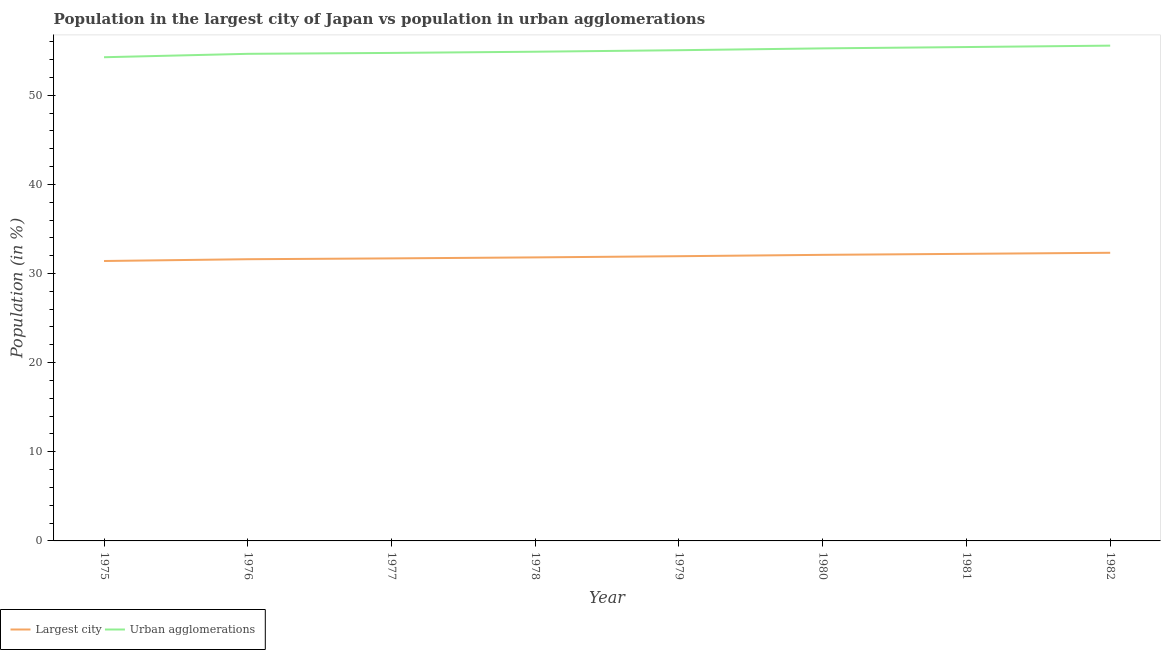Does the line corresponding to population in the largest city intersect with the line corresponding to population in urban agglomerations?
Make the answer very short. No. What is the population in the largest city in 1979?
Offer a very short reply. 31.94. Across all years, what is the maximum population in the largest city?
Provide a short and direct response. 32.32. Across all years, what is the minimum population in urban agglomerations?
Keep it short and to the point. 54.26. In which year was the population in urban agglomerations minimum?
Your answer should be very brief. 1975. What is the total population in the largest city in the graph?
Provide a succinct answer. 255.06. What is the difference between the population in the largest city in 1976 and that in 1978?
Make the answer very short. -0.21. What is the difference between the population in urban agglomerations in 1975 and the population in the largest city in 1980?
Keep it short and to the point. 22.17. What is the average population in the largest city per year?
Ensure brevity in your answer.  31.88. In the year 1975, what is the difference between the population in urban agglomerations and population in the largest city?
Provide a short and direct response. 22.86. In how many years, is the population in the largest city greater than 4 %?
Your answer should be compact. 8. What is the ratio of the population in the largest city in 1979 to that in 1982?
Make the answer very short. 0.99. What is the difference between the highest and the second highest population in urban agglomerations?
Provide a succinct answer. 0.16. What is the difference between the highest and the lowest population in the largest city?
Provide a succinct answer. 0.92. How many years are there in the graph?
Give a very brief answer. 8. What is the difference between two consecutive major ticks on the Y-axis?
Provide a succinct answer. 10. Are the values on the major ticks of Y-axis written in scientific E-notation?
Your response must be concise. No. Does the graph contain any zero values?
Ensure brevity in your answer.  No. Where does the legend appear in the graph?
Ensure brevity in your answer.  Bottom left. How many legend labels are there?
Give a very brief answer. 2. How are the legend labels stacked?
Make the answer very short. Horizontal. What is the title of the graph?
Offer a terse response. Population in the largest city of Japan vs population in urban agglomerations. Does "Not attending school" appear as one of the legend labels in the graph?
Your answer should be very brief. No. What is the label or title of the Y-axis?
Keep it short and to the point. Population (in %). What is the Population (in %) of Largest city in 1975?
Provide a short and direct response. 31.4. What is the Population (in %) in Urban agglomerations in 1975?
Offer a terse response. 54.26. What is the Population (in %) in Largest city in 1976?
Your answer should be very brief. 31.6. What is the Population (in %) of Urban agglomerations in 1976?
Your answer should be very brief. 54.64. What is the Population (in %) in Largest city in 1977?
Ensure brevity in your answer.  31.69. What is the Population (in %) of Urban agglomerations in 1977?
Provide a short and direct response. 54.74. What is the Population (in %) in Largest city in 1978?
Make the answer very short. 31.81. What is the Population (in %) in Urban agglomerations in 1978?
Provide a short and direct response. 54.88. What is the Population (in %) in Largest city in 1979?
Provide a short and direct response. 31.94. What is the Population (in %) in Urban agglomerations in 1979?
Make the answer very short. 55.05. What is the Population (in %) in Largest city in 1980?
Keep it short and to the point. 32.09. What is the Population (in %) of Urban agglomerations in 1980?
Provide a succinct answer. 55.25. What is the Population (in %) in Largest city in 1981?
Keep it short and to the point. 32.21. What is the Population (in %) of Urban agglomerations in 1981?
Your answer should be very brief. 55.4. What is the Population (in %) in Largest city in 1982?
Your response must be concise. 32.32. What is the Population (in %) in Urban agglomerations in 1982?
Your answer should be very brief. 55.56. Across all years, what is the maximum Population (in %) of Largest city?
Make the answer very short. 32.32. Across all years, what is the maximum Population (in %) in Urban agglomerations?
Provide a succinct answer. 55.56. Across all years, what is the minimum Population (in %) in Largest city?
Your answer should be very brief. 31.4. Across all years, what is the minimum Population (in %) in Urban agglomerations?
Your response must be concise. 54.26. What is the total Population (in %) of Largest city in the graph?
Your answer should be very brief. 255.06. What is the total Population (in %) of Urban agglomerations in the graph?
Your answer should be compact. 439.79. What is the difference between the Population (in %) in Largest city in 1975 and that in 1976?
Offer a very short reply. -0.2. What is the difference between the Population (in %) of Urban agglomerations in 1975 and that in 1976?
Offer a very short reply. -0.38. What is the difference between the Population (in %) of Largest city in 1975 and that in 1977?
Provide a succinct answer. -0.29. What is the difference between the Population (in %) in Urban agglomerations in 1975 and that in 1977?
Your answer should be compact. -0.48. What is the difference between the Population (in %) of Largest city in 1975 and that in 1978?
Offer a terse response. -0.4. What is the difference between the Population (in %) in Urban agglomerations in 1975 and that in 1978?
Make the answer very short. -0.62. What is the difference between the Population (in %) in Largest city in 1975 and that in 1979?
Offer a very short reply. -0.54. What is the difference between the Population (in %) in Urban agglomerations in 1975 and that in 1979?
Provide a short and direct response. -0.79. What is the difference between the Population (in %) of Largest city in 1975 and that in 1980?
Give a very brief answer. -0.69. What is the difference between the Population (in %) in Urban agglomerations in 1975 and that in 1980?
Provide a succinct answer. -0.99. What is the difference between the Population (in %) in Largest city in 1975 and that in 1981?
Give a very brief answer. -0.8. What is the difference between the Population (in %) in Urban agglomerations in 1975 and that in 1981?
Make the answer very short. -1.14. What is the difference between the Population (in %) in Largest city in 1975 and that in 1982?
Provide a succinct answer. -0.92. What is the difference between the Population (in %) of Urban agglomerations in 1975 and that in 1982?
Your answer should be very brief. -1.3. What is the difference between the Population (in %) of Largest city in 1976 and that in 1977?
Provide a short and direct response. -0.09. What is the difference between the Population (in %) of Urban agglomerations in 1976 and that in 1977?
Ensure brevity in your answer.  -0.1. What is the difference between the Population (in %) in Largest city in 1976 and that in 1978?
Give a very brief answer. -0.21. What is the difference between the Population (in %) of Urban agglomerations in 1976 and that in 1978?
Keep it short and to the point. -0.24. What is the difference between the Population (in %) of Largest city in 1976 and that in 1979?
Your response must be concise. -0.34. What is the difference between the Population (in %) of Urban agglomerations in 1976 and that in 1979?
Your response must be concise. -0.41. What is the difference between the Population (in %) of Largest city in 1976 and that in 1980?
Offer a very short reply. -0.49. What is the difference between the Population (in %) in Urban agglomerations in 1976 and that in 1980?
Keep it short and to the point. -0.61. What is the difference between the Population (in %) in Largest city in 1976 and that in 1981?
Your response must be concise. -0.61. What is the difference between the Population (in %) of Urban agglomerations in 1976 and that in 1981?
Make the answer very short. -0.76. What is the difference between the Population (in %) in Largest city in 1976 and that in 1982?
Make the answer very short. -0.72. What is the difference between the Population (in %) in Urban agglomerations in 1976 and that in 1982?
Keep it short and to the point. -0.92. What is the difference between the Population (in %) in Largest city in 1977 and that in 1978?
Provide a succinct answer. -0.11. What is the difference between the Population (in %) in Urban agglomerations in 1977 and that in 1978?
Your answer should be very brief. -0.14. What is the difference between the Population (in %) of Largest city in 1977 and that in 1979?
Give a very brief answer. -0.25. What is the difference between the Population (in %) in Urban agglomerations in 1977 and that in 1979?
Keep it short and to the point. -0.31. What is the difference between the Population (in %) in Largest city in 1977 and that in 1980?
Make the answer very short. -0.4. What is the difference between the Population (in %) of Urban agglomerations in 1977 and that in 1980?
Provide a succinct answer. -0.51. What is the difference between the Population (in %) of Largest city in 1977 and that in 1981?
Ensure brevity in your answer.  -0.51. What is the difference between the Population (in %) in Urban agglomerations in 1977 and that in 1981?
Offer a terse response. -0.66. What is the difference between the Population (in %) in Largest city in 1977 and that in 1982?
Your response must be concise. -0.63. What is the difference between the Population (in %) of Urban agglomerations in 1977 and that in 1982?
Your response must be concise. -0.82. What is the difference between the Population (in %) of Largest city in 1978 and that in 1979?
Your answer should be compact. -0.13. What is the difference between the Population (in %) in Urban agglomerations in 1978 and that in 1979?
Your answer should be compact. -0.17. What is the difference between the Population (in %) of Largest city in 1978 and that in 1980?
Ensure brevity in your answer.  -0.29. What is the difference between the Population (in %) of Urban agglomerations in 1978 and that in 1980?
Your response must be concise. -0.38. What is the difference between the Population (in %) in Largest city in 1978 and that in 1981?
Offer a very short reply. -0.4. What is the difference between the Population (in %) of Urban agglomerations in 1978 and that in 1981?
Your answer should be very brief. -0.53. What is the difference between the Population (in %) in Largest city in 1978 and that in 1982?
Your response must be concise. -0.52. What is the difference between the Population (in %) of Urban agglomerations in 1978 and that in 1982?
Your answer should be compact. -0.68. What is the difference between the Population (in %) of Largest city in 1979 and that in 1980?
Make the answer very short. -0.15. What is the difference between the Population (in %) in Urban agglomerations in 1979 and that in 1980?
Your response must be concise. -0.21. What is the difference between the Population (in %) of Largest city in 1979 and that in 1981?
Your answer should be very brief. -0.27. What is the difference between the Population (in %) in Urban agglomerations in 1979 and that in 1981?
Your answer should be compact. -0.35. What is the difference between the Population (in %) of Largest city in 1979 and that in 1982?
Ensure brevity in your answer.  -0.38. What is the difference between the Population (in %) of Urban agglomerations in 1979 and that in 1982?
Offer a terse response. -0.51. What is the difference between the Population (in %) of Largest city in 1980 and that in 1981?
Give a very brief answer. -0.11. What is the difference between the Population (in %) in Urban agglomerations in 1980 and that in 1981?
Provide a succinct answer. -0.15. What is the difference between the Population (in %) in Largest city in 1980 and that in 1982?
Provide a succinct answer. -0.23. What is the difference between the Population (in %) in Urban agglomerations in 1980 and that in 1982?
Provide a short and direct response. -0.31. What is the difference between the Population (in %) in Largest city in 1981 and that in 1982?
Make the answer very short. -0.12. What is the difference between the Population (in %) in Urban agglomerations in 1981 and that in 1982?
Offer a terse response. -0.16. What is the difference between the Population (in %) of Largest city in 1975 and the Population (in %) of Urban agglomerations in 1976?
Provide a short and direct response. -23.24. What is the difference between the Population (in %) of Largest city in 1975 and the Population (in %) of Urban agglomerations in 1977?
Keep it short and to the point. -23.34. What is the difference between the Population (in %) of Largest city in 1975 and the Population (in %) of Urban agglomerations in 1978?
Make the answer very short. -23.48. What is the difference between the Population (in %) of Largest city in 1975 and the Population (in %) of Urban agglomerations in 1979?
Make the answer very short. -23.65. What is the difference between the Population (in %) of Largest city in 1975 and the Population (in %) of Urban agglomerations in 1980?
Ensure brevity in your answer.  -23.85. What is the difference between the Population (in %) of Largest city in 1975 and the Population (in %) of Urban agglomerations in 1981?
Provide a succinct answer. -24. What is the difference between the Population (in %) of Largest city in 1975 and the Population (in %) of Urban agglomerations in 1982?
Your answer should be very brief. -24.16. What is the difference between the Population (in %) in Largest city in 1976 and the Population (in %) in Urban agglomerations in 1977?
Offer a very short reply. -23.14. What is the difference between the Population (in %) of Largest city in 1976 and the Population (in %) of Urban agglomerations in 1978?
Give a very brief answer. -23.28. What is the difference between the Population (in %) of Largest city in 1976 and the Population (in %) of Urban agglomerations in 1979?
Ensure brevity in your answer.  -23.45. What is the difference between the Population (in %) in Largest city in 1976 and the Population (in %) in Urban agglomerations in 1980?
Provide a short and direct response. -23.65. What is the difference between the Population (in %) of Largest city in 1976 and the Population (in %) of Urban agglomerations in 1981?
Keep it short and to the point. -23.8. What is the difference between the Population (in %) of Largest city in 1976 and the Population (in %) of Urban agglomerations in 1982?
Ensure brevity in your answer.  -23.96. What is the difference between the Population (in %) of Largest city in 1977 and the Population (in %) of Urban agglomerations in 1978?
Offer a very short reply. -23.18. What is the difference between the Population (in %) in Largest city in 1977 and the Population (in %) in Urban agglomerations in 1979?
Ensure brevity in your answer.  -23.36. What is the difference between the Population (in %) of Largest city in 1977 and the Population (in %) of Urban agglomerations in 1980?
Make the answer very short. -23.56. What is the difference between the Population (in %) in Largest city in 1977 and the Population (in %) in Urban agglomerations in 1981?
Ensure brevity in your answer.  -23.71. What is the difference between the Population (in %) of Largest city in 1977 and the Population (in %) of Urban agglomerations in 1982?
Your answer should be very brief. -23.87. What is the difference between the Population (in %) in Largest city in 1978 and the Population (in %) in Urban agglomerations in 1979?
Provide a short and direct response. -23.24. What is the difference between the Population (in %) of Largest city in 1978 and the Population (in %) of Urban agglomerations in 1980?
Offer a very short reply. -23.45. What is the difference between the Population (in %) in Largest city in 1978 and the Population (in %) in Urban agglomerations in 1981?
Your answer should be compact. -23.6. What is the difference between the Population (in %) in Largest city in 1978 and the Population (in %) in Urban agglomerations in 1982?
Ensure brevity in your answer.  -23.75. What is the difference between the Population (in %) of Largest city in 1979 and the Population (in %) of Urban agglomerations in 1980?
Provide a succinct answer. -23.32. What is the difference between the Population (in %) of Largest city in 1979 and the Population (in %) of Urban agglomerations in 1981?
Give a very brief answer. -23.46. What is the difference between the Population (in %) in Largest city in 1979 and the Population (in %) in Urban agglomerations in 1982?
Provide a short and direct response. -23.62. What is the difference between the Population (in %) in Largest city in 1980 and the Population (in %) in Urban agglomerations in 1981?
Offer a terse response. -23.31. What is the difference between the Population (in %) of Largest city in 1980 and the Population (in %) of Urban agglomerations in 1982?
Ensure brevity in your answer.  -23.47. What is the difference between the Population (in %) of Largest city in 1981 and the Population (in %) of Urban agglomerations in 1982?
Provide a short and direct response. -23.35. What is the average Population (in %) of Largest city per year?
Make the answer very short. 31.88. What is the average Population (in %) in Urban agglomerations per year?
Your answer should be compact. 54.97. In the year 1975, what is the difference between the Population (in %) in Largest city and Population (in %) in Urban agglomerations?
Make the answer very short. -22.86. In the year 1976, what is the difference between the Population (in %) in Largest city and Population (in %) in Urban agglomerations?
Provide a short and direct response. -23.04. In the year 1977, what is the difference between the Population (in %) in Largest city and Population (in %) in Urban agglomerations?
Make the answer very short. -23.05. In the year 1978, what is the difference between the Population (in %) of Largest city and Population (in %) of Urban agglomerations?
Offer a terse response. -23.07. In the year 1979, what is the difference between the Population (in %) in Largest city and Population (in %) in Urban agglomerations?
Give a very brief answer. -23.11. In the year 1980, what is the difference between the Population (in %) of Largest city and Population (in %) of Urban agglomerations?
Provide a succinct answer. -23.16. In the year 1981, what is the difference between the Population (in %) of Largest city and Population (in %) of Urban agglomerations?
Your answer should be very brief. -23.2. In the year 1982, what is the difference between the Population (in %) in Largest city and Population (in %) in Urban agglomerations?
Your answer should be very brief. -23.24. What is the ratio of the Population (in %) in Largest city in 1975 to that in 1976?
Provide a succinct answer. 0.99. What is the ratio of the Population (in %) in Largest city in 1975 to that in 1978?
Your response must be concise. 0.99. What is the ratio of the Population (in %) in Urban agglomerations in 1975 to that in 1978?
Offer a very short reply. 0.99. What is the ratio of the Population (in %) of Largest city in 1975 to that in 1979?
Your response must be concise. 0.98. What is the ratio of the Population (in %) of Urban agglomerations in 1975 to that in 1979?
Offer a very short reply. 0.99. What is the ratio of the Population (in %) of Largest city in 1975 to that in 1980?
Make the answer very short. 0.98. What is the ratio of the Population (in %) in Urban agglomerations in 1975 to that in 1981?
Ensure brevity in your answer.  0.98. What is the ratio of the Population (in %) in Largest city in 1975 to that in 1982?
Your answer should be compact. 0.97. What is the ratio of the Population (in %) of Urban agglomerations in 1975 to that in 1982?
Provide a succinct answer. 0.98. What is the ratio of the Population (in %) of Urban agglomerations in 1976 to that in 1977?
Offer a very short reply. 1. What is the ratio of the Population (in %) in Largest city in 1976 to that in 1980?
Give a very brief answer. 0.98. What is the ratio of the Population (in %) of Urban agglomerations in 1976 to that in 1980?
Your answer should be compact. 0.99. What is the ratio of the Population (in %) in Largest city in 1976 to that in 1981?
Ensure brevity in your answer.  0.98. What is the ratio of the Population (in %) of Urban agglomerations in 1976 to that in 1981?
Ensure brevity in your answer.  0.99. What is the ratio of the Population (in %) in Largest city in 1976 to that in 1982?
Make the answer very short. 0.98. What is the ratio of the Population (in %) of Urban agglomerations in 1976 to that in 1982?
Your answer should be compact. 0.98. What is the ratio of the Population (in %) of Largest city in 1977 to that in 1978?
Give a very brief answer. 1. What is the ratio of the Population (in %) in Urban agglomerations in 1977 to that in 1978?
Your answer should be very brief. 1. What is the ratio of the Population (in %) in Largest city in 1977 to that in 1979?
Your answer should be compact. 0.99. What is the ratio of the Population (in %) of Largest city in 1977 to that in 1980?
Your response must be concise. 0.99. What is the ratio of the Population (in %) in Urban agglomerations in 1977 to that in 1980?
Your response must be concise. 0.99. What is the ratio of the Population (in %) of Largest city in 1977 to that in 1981?
Offer a very short reply. 0.98. What is the ratio of the Population (in %) in Urban agglomerations in 1977 to that in 1981?
Provide a succinct answer. 0.99. What is the ratio of the Population (in %) of Largest city in 1977 to that in 1982?
Provide a succinct answer. 0.98. What is the ratio of the Population (in %) of Urban agglomerations in 1978 to that in 1979?
Provide a short and direct response. 1. What is the ratio of the Population (in %) of Urban agglomerations in 1978 to that in 1980?
Give a very brief answer. 0.99. What is the ratio of the Population (in %) in Largest city in 1978 to that in 1981?
Provide a short and direct response. 0.99. What is the ratio of the Population (in %) in Urban agglomerations in 1978 to that in 1981?
Offer a terse response. 0.99. What is the ratio of the Population (in %) in Largest city in 1978 to that in 1982?
Offer a terse response. 0.98. What is the ratio of the Population (in %) of Urban agglomerations in 1978 to that in 1982?
Provide a short and direct response. 0.99. What is the ratio of the Population (in %) in Urban agglomerations in 1979 to that in 1981?
Your response must be concise. 0.99. What is the ratio of the Population (in %) in Urban agglomerations in 1980 to that in 1982?
Give a very brief answer. 0.99. What is the ratio of the Population (in %) of Urban agglomerations in 1981 to that in 1982?
Offer a terse response. 1. What is the difference between the highest and the second highest Population (in %) of Largest city?
Make the answer very short. 0.12. What is the difference between the highest and the second highest Population (in %) of Urban agglomerations?
Keep it short and to the point. 0.16. What is the difference between the highest and the lowest Population (in %) in Largest city?
Your answer should be compact. 0.92. What is the difference between the highest and the lowest Population (in %) of Urban agglomerations?
Offer a very short reply. 1.3. 